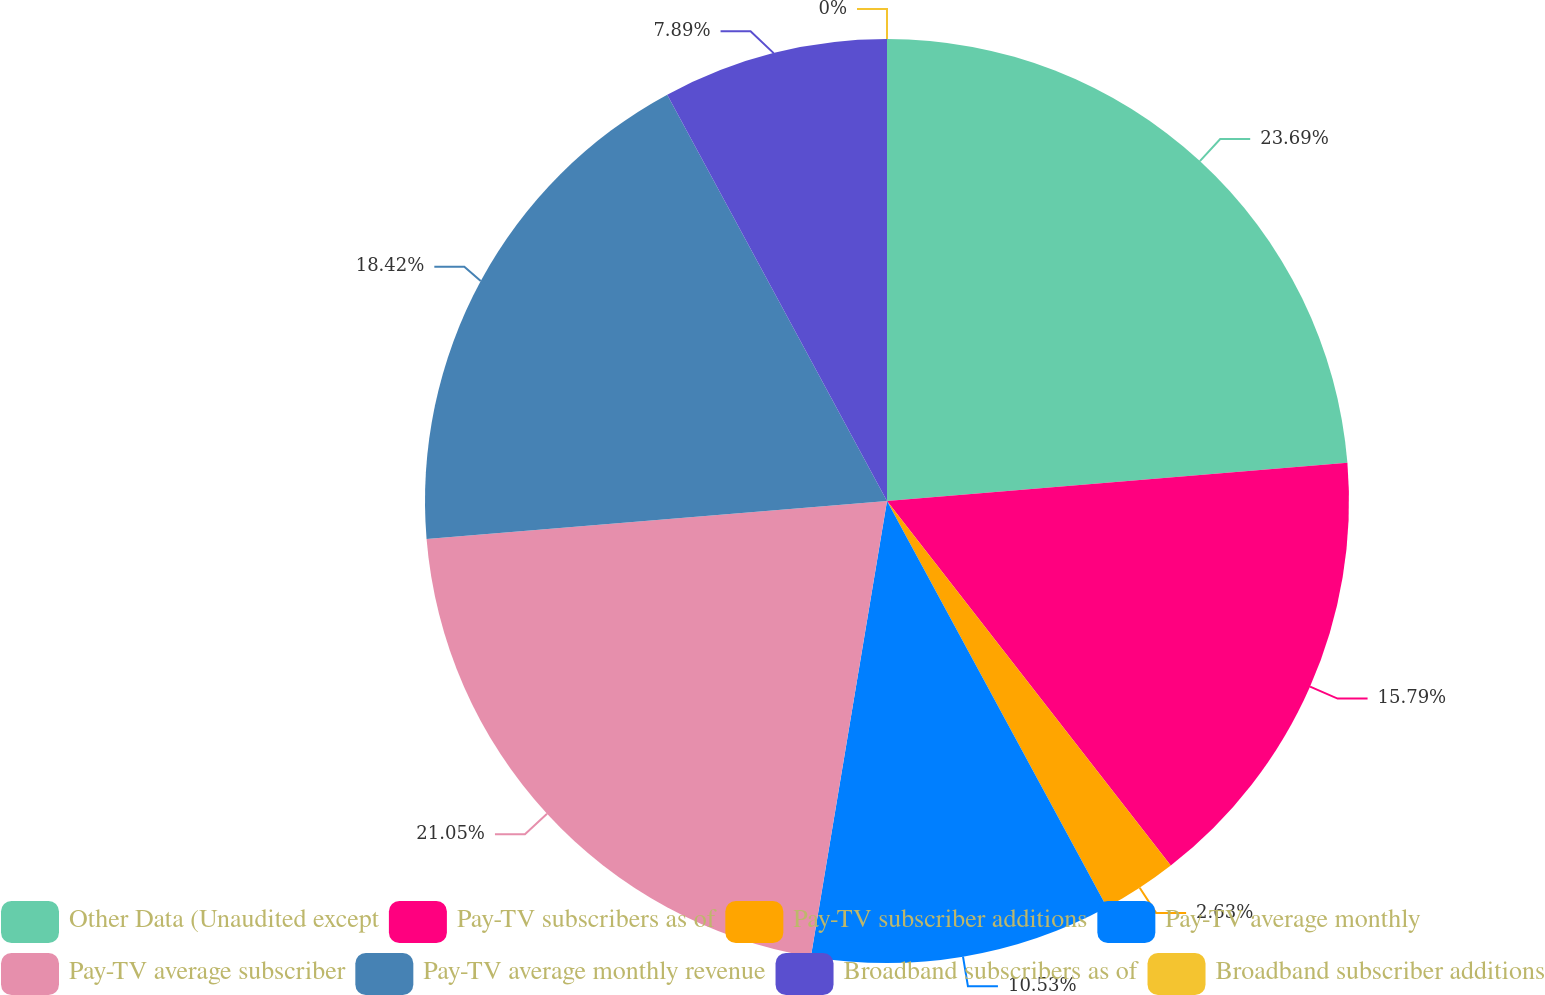Convert chart. <chart><loc_0><loc_0><loc_500><loc_500><pie_chart><fcel>Other Data (Unaudited except<fcel>Pay-TV subscribers as of<fcel>Pay-TV subscriber additions<fcel>Pay-TV average monthly<fcel>Pay-TV average subscriber<fcel>Pay-TV average monthly revenue<fcel>Broadband subscribers as of<fcel>Broadband subscriber additions<nl><fcel>23.68%<fcel>15.79%<fcel>2.63%<fcel>10.53%<fcel>21.05%<fcel>18.42%<fcel>7.89%<fcel>0.0%<nl></chart> 